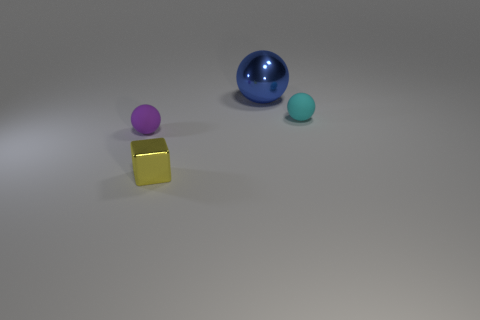The tiny ball behind the tiny rubber sphere that is left of the big ball behind the tiny metal block is made of what material?
Give a very brief answer. Rubber. There is a rubber ball that is right of the blue metallic thing; is it the same size as the metallic object that is on the right side of the tiny yellow metal object?
Keep it short and to the point. No. What number of other things are the same material as the block?
Provide a succinct answer. 1. How many metal objects are blue things or tiny cyan balls?
Offer a terse response. 1. Is the number of blue objects less than the number of balls?
Your answer should be very brief. Yes. Do the cyan sphere and the thing that is to the left of the tiny yellow shiny object have the same size?
Your answer should be very brief. Yes. Is there anything else that has the same shape as the yellow object?
Offer a terse response. No. How big is the cube?
Your answer should be compact. Small. Is the number of blue spheres that are left of the yellow block less than the number of purple balls?
Make the answer very short. Yes. Does the yellow metal block have the same size as the purple thing?
Keep it short and to the point. Yes. 